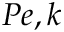<formula> <loc_0><loc_0><loc_500><loc_500>P e , k</formula> 